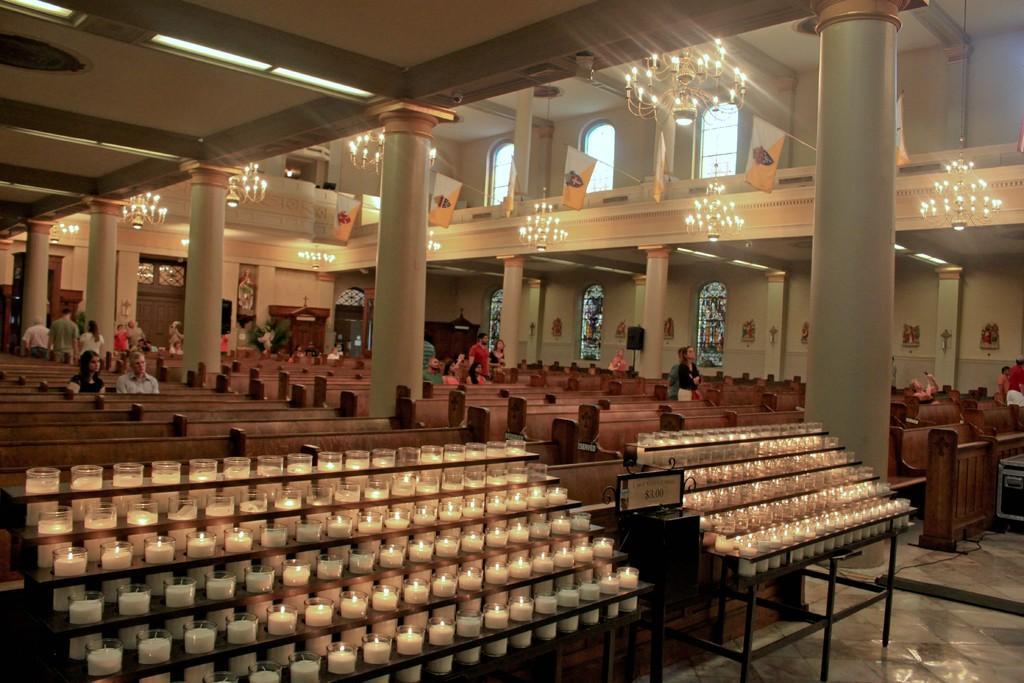Please provide a concise description of this image. In this image we can see the inside view of the church which includes candles, near that we can see wooden benches. And we can see some people sitting and some are standing. And we can see the pillars, near that we can see ceiling with the lights, we can see hanging lamps on the right. And we can see the windows. 